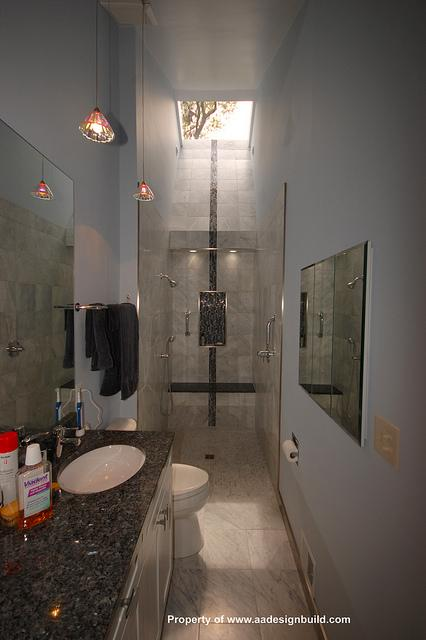What color is the fluid in the small container with the white cap on the top?

Choices:
A) purple
B) red
C) blue
D) green red 